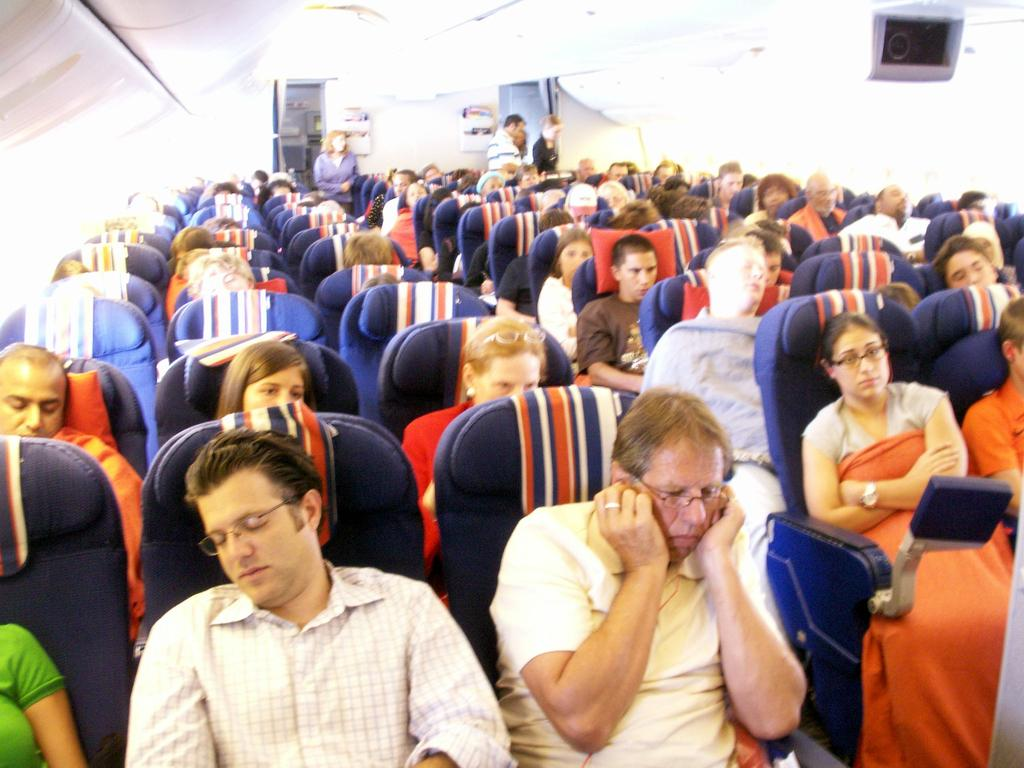What are the persons in the image doing? The persons in the image are sitting in chairs. Can you describe the background of the image? There are four persons standing in the background of the image. Is there anything present in the top right corner of the image? Yes, there is an object in the right top corner of the image. What type of shoes are the boys wearing in the image? There is no boy present in the image, and therefore no shoes to describe. 